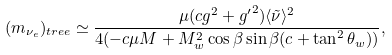Convert formula to latex. <formula><loc_0><loc_0><loc_500><loc_500>( m _ { \nu _ { e } } ) _ { t r e e } \simeq \frac { \mu ( c g ^ { 2 } + { g ^ { \prime } } ^ { 2 } ) \langle \tilde { \nu } \rangle ^ { 2 } } { 4 ( - c \mu M + M _ { w } ^ { 2 } \cos \beta \sin \beta ( c + \tan ^ { 2 } \theta _ { w } ) ) } ,</formula> 